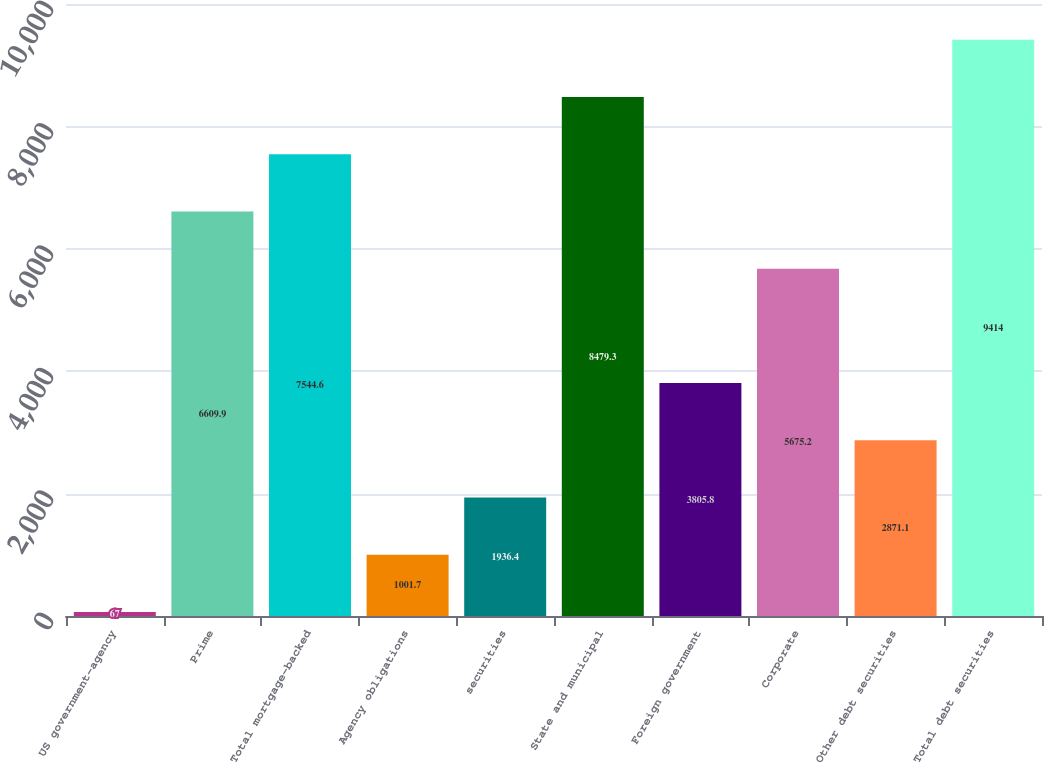<chart> <loc_0><loc_0><loc_500><loc_500><bar_chart><fcel>US government-agency<fcel>Prime<fcel>Total mortgage-backed<fcel>Agency obligations<fcel>securities<fcel>State and municipal<fcel>Foreign government<fcel>Corporate<fcel>Other debt securities<fcel>Total debt securities<nl><fcel>67<fcel>6609.9<fcel>7544.6<fcel>1001.7<fcel>1936.4<fcel>8479.3<fcel>3805.8<fcel>5675.2<fcel>2871.1<fcel>9414<nl></chart> 